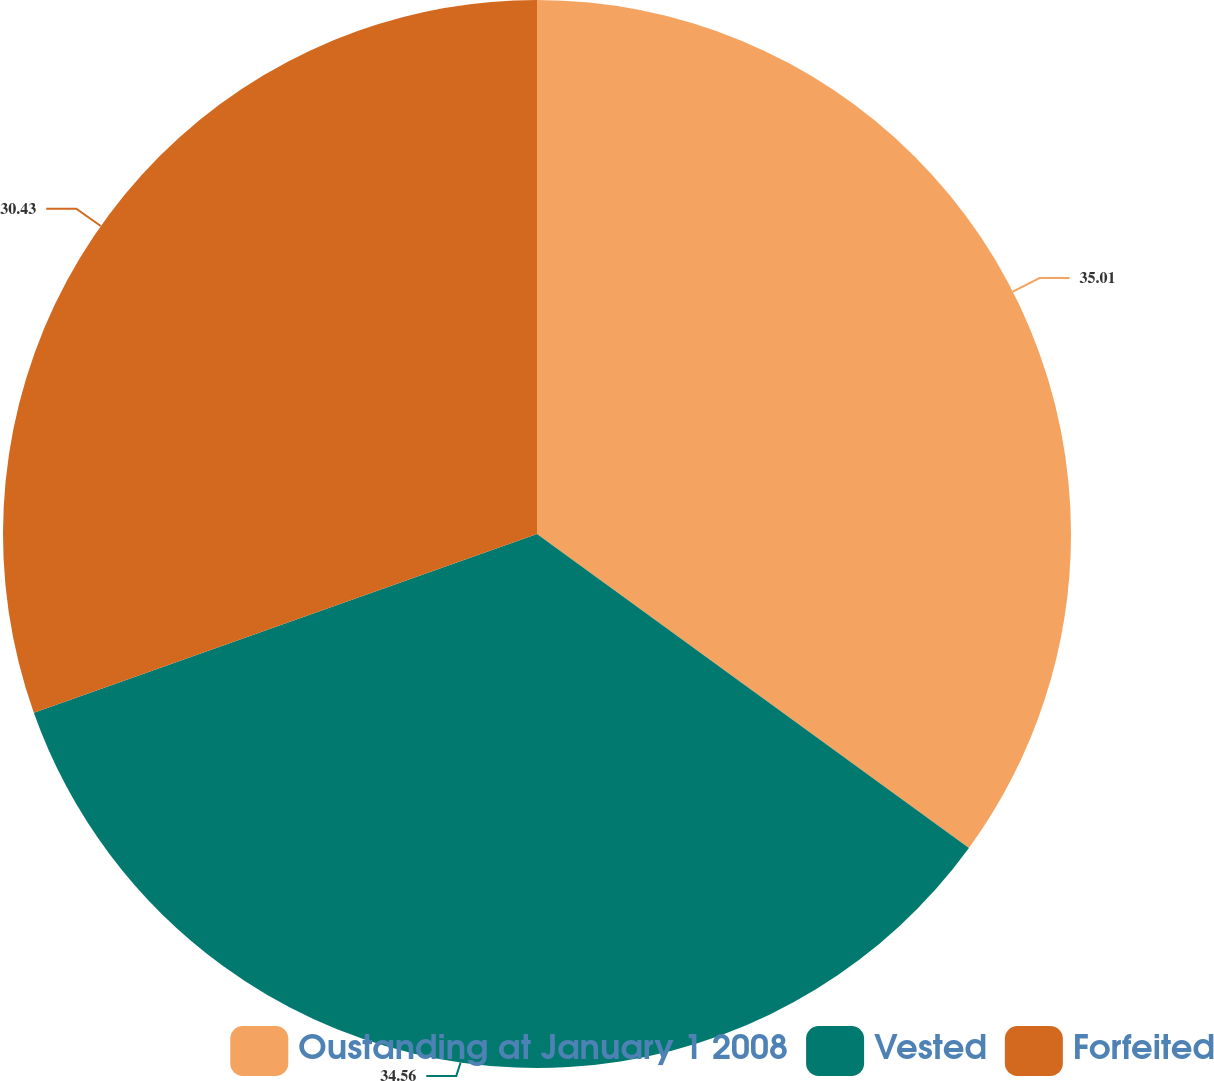Convert chart to OTSL. <chart><loc_0><loc_0><loc_500><loc_500><pie_chart><fcel>Oustanding at January 1 2008<fcel>Vested<fcel>Forfeited<nl><fcel>35.0%<fcel>34.56%<fcel>30.43%<nl></chart> 